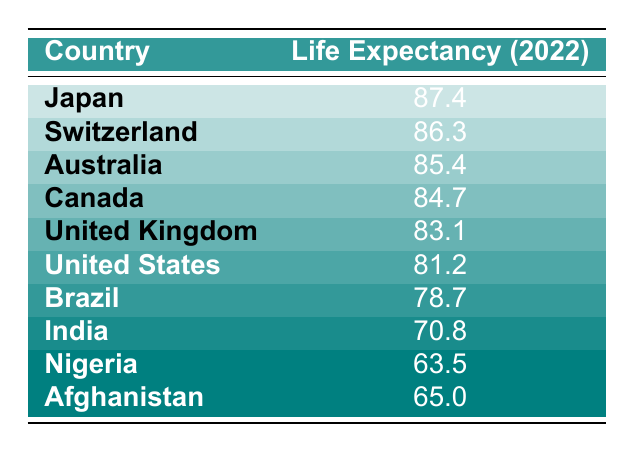What is the life expectancy of women in Japan? The table shows that the life expectancy for women in Japan in 2022 is 87.4 years.
Answer: 87.4 Which country has the lowest life expectancy among the listed countries? By examining the life expectancy values, Nigeria has the lowest figure at 63.5 years.
Answer: Nigeria What is the difference in life expectancy between Australia and the United Kingdom? The life expectancy for Australia is 85.4 years, and for the United Kingdom, it is 83.1 years. Thus, the difference is 85.4 - 83.1 = 2.3 years.
Answer: 2.3 Is the life expectancy of women in the United States higher than that in Brazil? In the table, the life expectancy for women in the United States is 81.2 years, and for Brazil, it is 78.7 years. Since 81.2 is greater than 78.7, the statement is true.
Answer: Yes What country has a life expectancy that is closest to 70 years? Looking at the table, India has a life expectancy of 70.8, which is the closest value over 70 years compared to the others provided.
Answer: India What is the average life expectancy of the top three countries in the table? The top three countries are Japan (87.4), Switzerland (86.3), and Australia (85.4). Summing these gives 87.4 + 86.3 + 85.4 = 259.1. There are three countries, so the average is 259.1 / 3 = 86.367, which rounds to 86.4.
Answer: 86.4 Is the life expectancy of women in Afghanistan greater than that in Nigeria? In the table, Afghanistan's life expectancy is 65.0 years, and Nigeria's is 63.5 years. Since 65.0 is greater than 63.5, the statement is true.
Answer: Yes Which country has a difference of 5 years between their life expectancy and that of women in India? India's life expectancy is 70.8 years. If we look for a country with a life expectancy of 75.8 years (70.8 + 5), none match. However, if we look for the difference, Nigeria (63.5) and Afghanistan (65.0) are both more than 5 years lower. No country meets the criteria.
Answer: None 